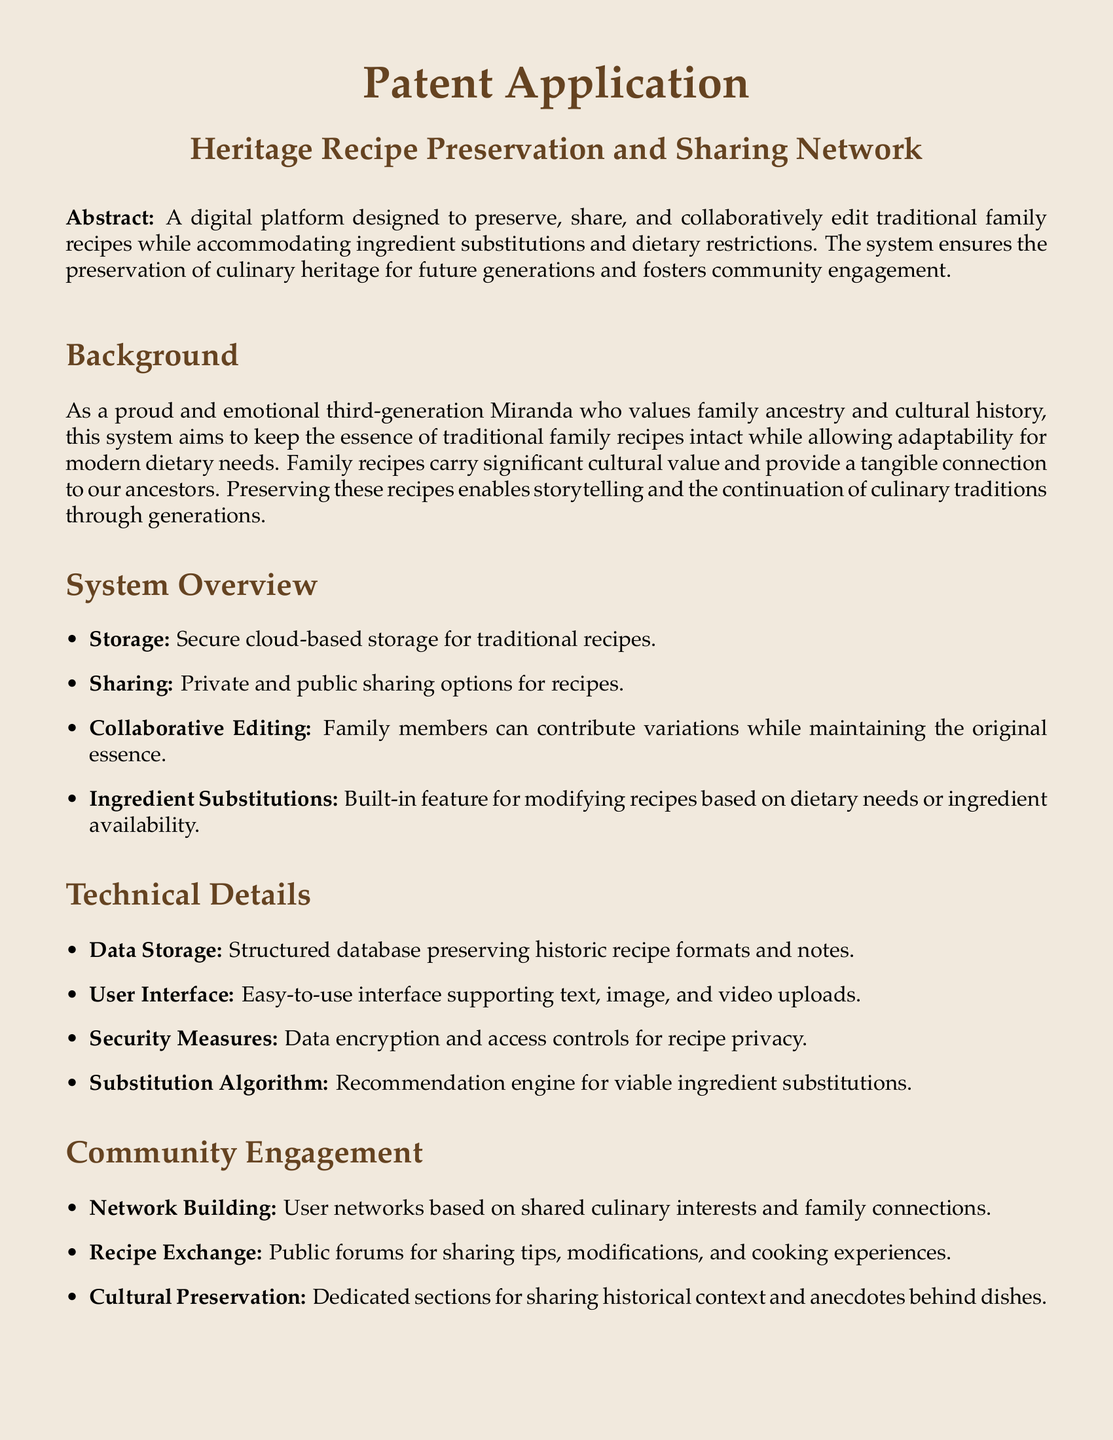What is the title of the patent application? The title of the patent application is presented prominently under the heading section, which is "Heritage Recipe Preservation and Sharing Network."
Answer: Heritage Recipe Preservation and Sharing Network What is the main purpose of the platform? The main purpose of the platform is stated in the abstract, which focuses on preserving and sharing traditional family recipes.
Answer: Preserve, share, and collaboratively edit traditional family recipes What type of storage does the system offer? The system offers cloud-based storage, as mentioned in the system overview section.
Answer: Cloud-based storage What feature accommodates dietary restrictions? The feature that accommodates dietary restrictions is mentioned specifically in the system overview section regarding ingredient substitutions.
Answer: Ingredient Substitutions What is one security measure mentioned for recipe privacy? The document lists security measures, one of which is data encryption as part of maintaining recipe privacy.
Answer: Data encryption Which section discusses community engagement? The section that discusses community engagement is labeled "Community Engagement" in the document.
Answer: Community Engagement What is the second claim of the patent? The second claim discusses a collaborative editing tool allowing family members to edit and enhance traditional recipes while maintaining version control.
Answer: Collaborative Editing Tool How many claims are listed in the document? The document specifically enumerates the claims, providing a count of three total claims listed.
Answer: Three What does the substitution algorithm suggest? The substitution algorithm suggests viable ingredient substitutions based on the document's technical details.
Answer: Ingredient substitutions In what context are historical anecdotes shared according to the document? The document refers to sharing historical context and anecdotes behind dishes in the "Cultural Preservation" subsection of community engagement.
Answer: Cultural Preservation 